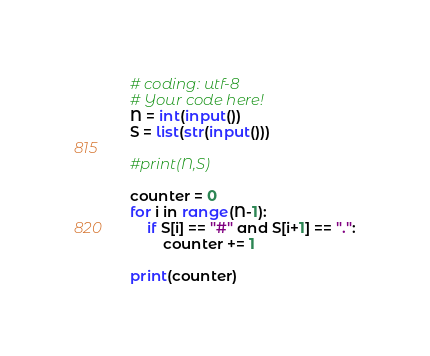Convert code to text. <code><loc_0><loc_0><loc_500><loc_500><_Python_># coding: utf-8
# Your code here!
N = int(input())
S = list(str(input()))

#print(N,S)

counter = 0
for i in range(N-1):
    if S[i] == "#" and S[i+1] == ".":
        counter += 1

print(counter)</code> 